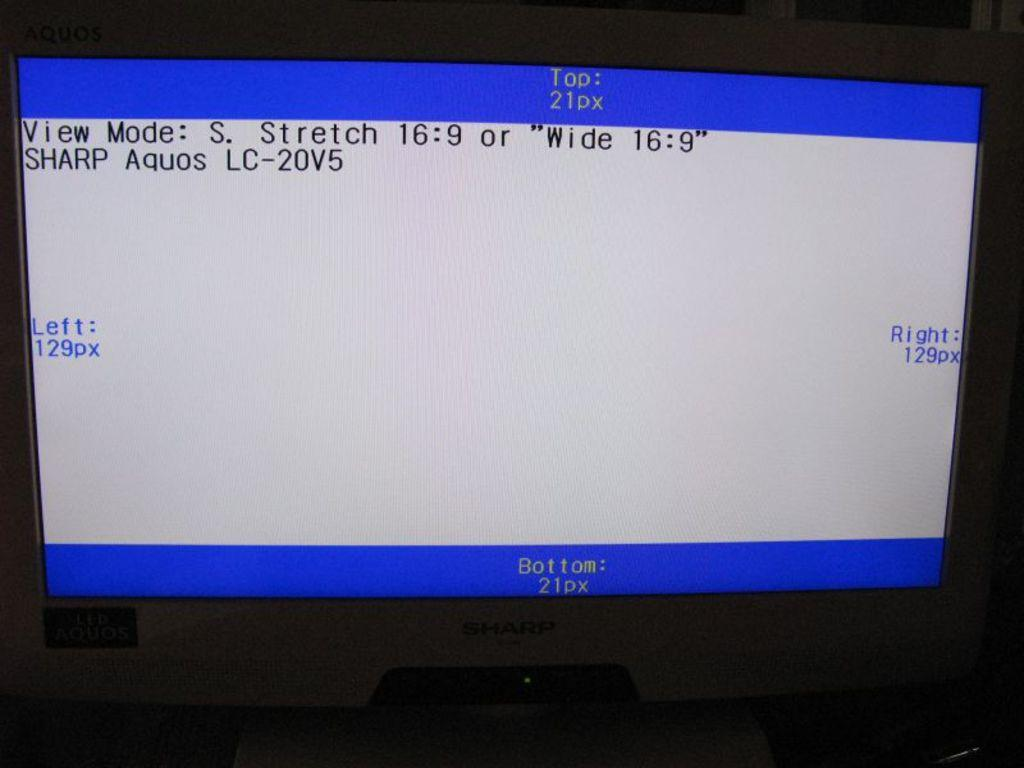<image>
Present a compact description of the photo's key features. a computer monitor has a white black and blue screen displayed that reads view mode. 